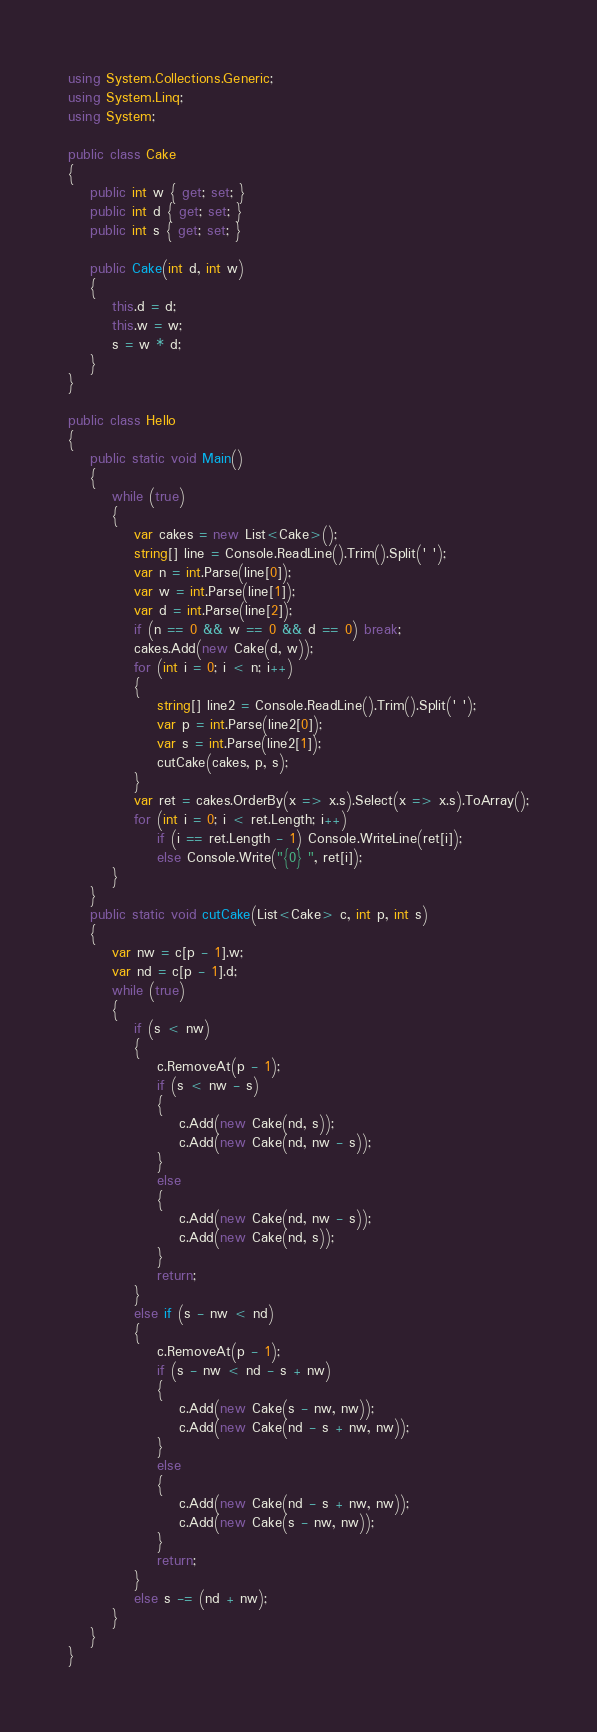Convert code to text. <code><loc_0><loc_0><loc_500><loc_500><_C#_>using System.Collections.Generic;
using System.Linq;
using System;

public class Cake
{
    public int w { get; set; }
    public int d { get; set; }
    public int s { get; set; }

    public Cake(int d, int w)
    {
        this.d = d;
        this.w = w;
        s = w * d;
    }
}

public class Hello
{
    public static void Main()
    {
        while (true)
        {
            var cakes = new List<Cake>();
            string[] line = Console.ReadLine().Trim().Split(' ');
            var n = int.Parse(line[0]);
            var w = int.Parse(line[1]);
            var d = int.Parse(line[2]);
            if (n == 0 && w == 0 && d == 0) break;
            cakes.Add(new Cake(d, w));
            for (int i = 0; i < n; i++)
            {
                string[] line2 = Console.ReadLine().Trim().Split(' ');
                var p = int.Parse(line2[0]);
                var s = int.Parse(line2[1]);
                cutCake(cakes, p, s);
            }
            var ret = cakes.OrderBy(x => x.s).Select(x => x.s).ToArray();
            for (int i = 0; i < ret.Length; i++)
                if (i == ret.Length - 1) Console.WriteLine(ret[i]);
                else Console.Write("{0} ", ret[i]);
        }
    }
    public static void cutCake(List<Cake> c, int p, int s)
    {
        var nw = c[p - 1].w;
        var nd = c[p - 1].d;
        while (true)
        {
            if (s < nw)
            {
                c.RemoveAt(p - 1);
                if (s < nw - s)
                {
                    c.Add(new Cake(nd, s));
                    c.Add(new Cake(nd, nw - s));
                }
                else
                {
                    c.Add(new Cake(nd, nw - s));
                    c.Add(new Cake(nd, s));
                }
                return;
            }
            else if (s - nw < nd)
            {
                c.RemoveAt(p - 1);
                if (s - nw < nd - s + nw)
                {
                    c.Add(new Cake(s - nw, nw));
                    c.Add(new Cake(nd - s + nw, nw));
                }
                else
                {
                    c.Add(new Cake(nd - s + nw, nw));
                    c.Add(new Cake(s - nw, nw));
                }
                return;
            }
            else s -= (nd + nw);
        }
    }
}</code> 